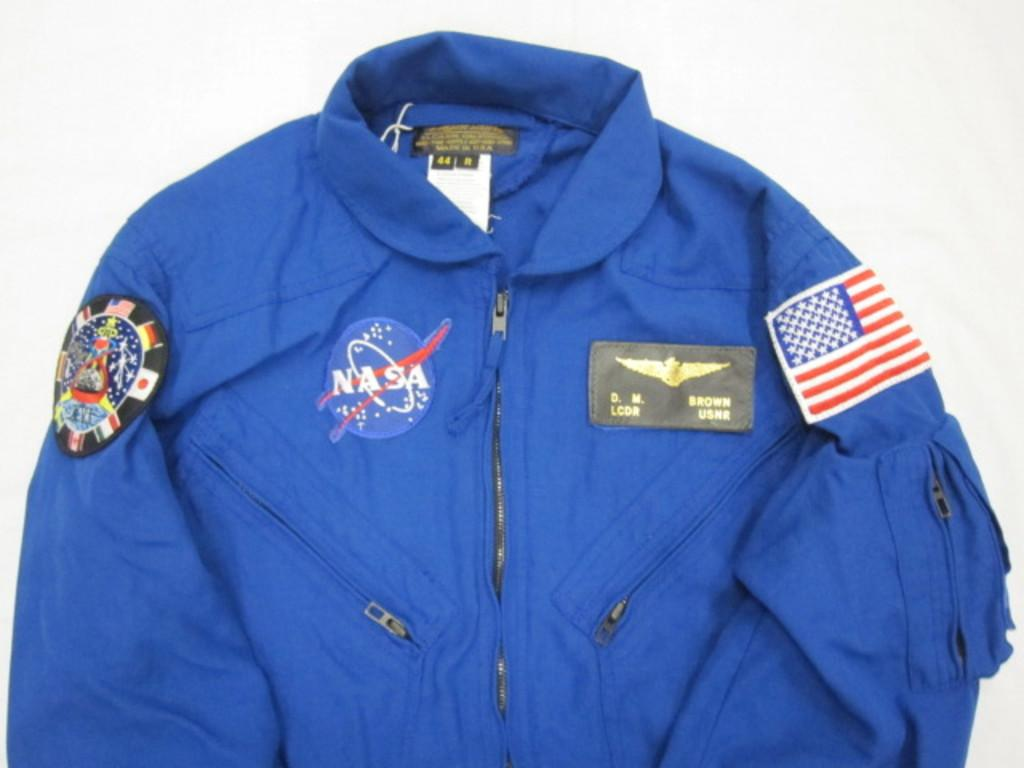<image>
Present a compact description of the photo's key features. the word NASA is on a blue coat 